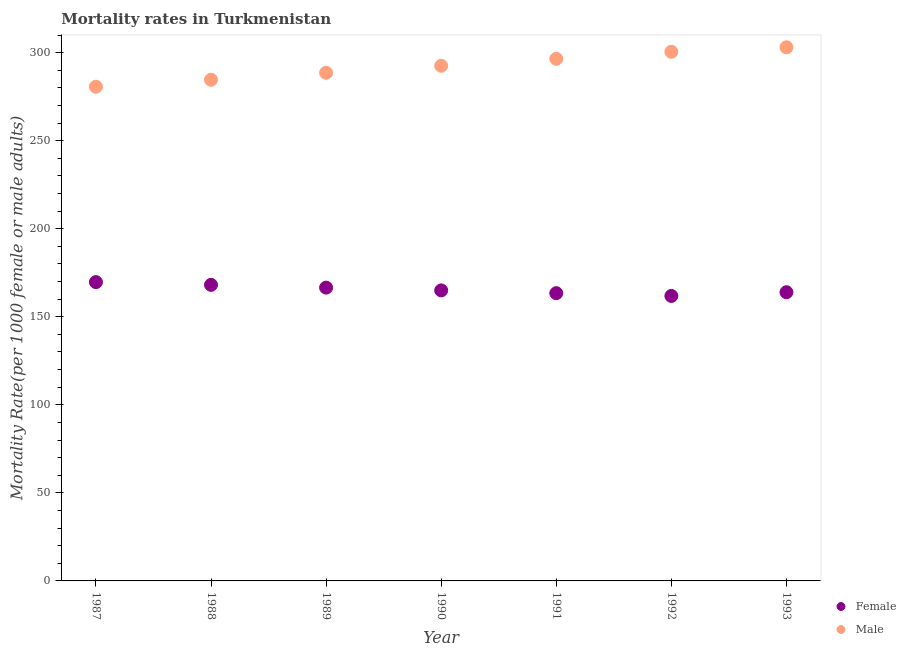How many different coloured dotlines are there?
Make the answer very short. 2. What is the male mortality rate in 1988?
Offer a very short reply. 284.61. Across all years, what is the maximum female mortality rate?
Your answer should be very brief. 169.69. Across all years, what is the minimum male mortality rate?
Offer a terse response. 280.64. In which year was the male mortality rate minimum?
Make the answer very short. 1987. What is the total female mortality rate in the graph?
Your response must be concise. 1158.54. What is the difference between the female mortality rate in 1988 and that in 1990?
Offer a very short reply. 3.14. What is the difference between the female mortality rate in 1990 and the male mortality rate in 1991?
Ensure brevity in your answer.  -131.53. What is the average female mortality rate per year?
Your response must be concise. 165.51. In the year 1993, what is the difference between the female mortality rate and male mortality rate?
Keep it short and to the point. -139.07. What is the ratio of the female mortality rate in 1987 to that in 1989?
Your response must be concise. 1.02. Is the difference between the male mortality rate in 1987 and 1992 greater than the difference between the female mortality rate in 1987 and 1992?
Make the answer very short. No. What is the difference between the highest and the second highest male mortality rate?
Your answer should be very brief. 2.55. What is the difference between the highest and the lowest male mortality rate?
Your answer should be compact. 22.38. In how many years, is the female mortality rate greater than the average female mortality rate taken over all years?
Offer a terse response. 3. Is the sum of the male mortality rate in 1987 and 1990 greater than the maximum female mortality rate across all years?
Give a very brief answer. Yes. Does the male mortality rate monotonically increase over the years?
Make the answer very short. Yes. Is the male mortality rate strictly less than the female mortality rate over the years?
Your answer should be very brief. No. How many dotlines are there?
Your answer should be very brief. 2. What is the difference between two consecutive major ticks on the Y-axis?
Your response must be concise. 50. Are the values on the major ticks of Y-axis written in scientific E-notation?
Your answer should be very brief. No. Does the graph contain any zero values?
Provide a short and direct response. No. Where does the legend appear in the graph?
Offer a terse response. Bottom right. How many legend labels are there?
Offer a very short reply. 2. What is the title of the graph?
Provide a succinct answer. Mortality rates in Turkmenistan. Does "Secondary school" appear as one of the legend labels in the graph?
Your response must be concise. No. What is the label or title of the Y-axis?
Ensure brevity in your answer.  Mortality Rate(per 1000 female or male adults). What is the Mortality Rate(per 1000 female or male adults) of Female in 1987?
Your answer should be compact. 169.69. What is the Mortality Rate(per 1000 female or male adults) of Male in 1987?
Give a very brief answer. 280.64. What is the Mortality Rate(per 1000 female or male adults) of Female in 1988?
Your answer should be very brief. 168.12. What is the Mortality Rate(per 1000 female or male adults) of Male in 1988?
Provide a succinct answer. 284.61. What is the Mortality Rate(per 1000 female or male adults) of Female in 1989?
Give a very brief answer. 166.55. What is the Mortality Rate(per 1000 female or male adults) in Male in 1989?
Make the answer very short. 288.57. What is the Mortality Rate(per 1000 female or male adults) of Female in 1990?
Give a very brief answer. 164.98. What is the Mortality Rate(per 1000 female or male adults) of Male in 1990?
Your answer should be compact. 292.54. What is the Mortality Rate(per 1000 female or male adults) of Female in 1991?
Offer a very short reply. 163.41. What is the Mortality Rate(per 1000 female or male adults) in Male in 1991?
Ensure brevity in your answer.  296.5. What is the Mortality Rate(per 1000 female or male adults) of Female in 1992?
Keep it short and to the point. 161.84. What is the Mortality Rate(per 1000 female or male adults) in Male in 1992?
Ensure brevity in your answer.  300.47. What is the Mortality Rate(per 1000 female or male adults) of Female in 1993?
Provide a succinct answer. 163.95. What is the Mortality Rate(per 1000 female or male adults) in Male in 1993?
Make the answer very short. 303.02. Across all years, what is the maximum Mortality Rate(per 1000 female or male adults) of Female?
Offer a very short reply. 169.69. Across all years, what is the maximum Mortality Rate(per 1000 female or male adults) of Male?
Make the answer very short. 303.02. Across all years, what is the minimum Mortality Rate(per 1000 female or male adults) of Female?
Keep it short and to the point. 161.84. Across all years, what is the minimum Mortality Rate(per 1000 female or male adults) of Male?
Provide a short and direct response. 280.64. What is the total Mortality Rate(per 1000 female or male adults) of Female in the graph?
Your answer should be very brief. 1158.54. What is the total Mortality Rate(per 1000 female or male adults) of Male in the graph?
Your answer should be very brief. 2046.35. What is the difference between the Mortality Rate(per 1000 female or male adults) in Female in 1987 and that in 1988?
Ensure brevity in your answer.  1.57. What is the difference between the Mortality Rate(per 1000 female or male adults) of Male in 1987 and that in 1988?
Give a very brief answer. -3.97. What is the difference between the Mortality Rate(per 1000 female or male adults) in Female in 1987 and that in 1989?
Your answer should be compact. 3.14. What is the difference between the Mortality Rate(per 1000 female or male adults) in Male in 1987 and that in 1989?
Offer a very short reply. -7.93. What is the difference between the Mortality Rate(per 1000 female or male adults) of Female in 1987 and that in 1990?
Offer a very short reply. 4.71. What is the difference between the Mortality Rate(per 1000 female or male adults) of Male in 1987 and that in 1990?
Provide a succinct answer. -11.9. What is the difference between the Mortality Rate(per 1000 female or male adults) of Female in 1987 and that in 1991?
Provide a succinct answer. 6.29. What is the difference between the Mortality Rate(per 1000 female or male adults) in Male in 1987 and that in 1991?
Your answer should be compact. -15.86. What is the difference between the Mortality Rate(per 1000 female or male adults) of Female in 1987 and that in 1992?
Your answer should be compact. 7.86. What is the difference between the Mortality Rate(per 1000 female or male adults) in Male in 1987 and that in 1992?
Your answer should be very brief. -19.83. What is the difference between the Mortality Rate(per 1000 female or male adults) of Female in 1987 and that in 1993?
Provide a succinct answer. 5.75. What is the difference between the Mortality Rate(per 1000 female or male adults) in Male in 1987 and that in 1993?
Your response must be concise. -22.38. What is the difference between the Mortality Rate(per 1000 female or male adults) in Female in 1988 and that in 1989?
Offer a very short reply. 1.57. What is the difference between the Mortality Rate(per 1000 female or male adults) in Male in 1988 and that in 1989?
Offer a terse response. -3.97. What is the difference between the Mortality Rate(per 1000 female or male adults) of Female in 1988 and that in 1990?
Offer a terse response. 3.14. What is the difference between the Mortality Rate(per 1000 female or male adults) in Male in 1988 and that in 1990?
Give a very brief answer. -7.93. What is the difference between the Mortality Rate(per 1000 female or male adults) in Female in 1988 and that in 1991?
Provide a succinct answer. 4.71. What is the difference between the Mortality Rate(per 1000 female or male adults) in Male in 1988 and that in 1991?
Provide a short and direct response. -11.9. What is the difference between the Mortality Rate(per 1000 female or male adults) in Female in 1988 and that in 1992?
Provide a succinct answer. 6.29. What is the difference between the Mortality Rate(per 1000 female or male adults) in Male in 1988 and that in 1992?
Your answer should be compact. -15.86. What is the difference between the Mortality Rate(per 1000 female or male adults) in Female in 1988 and that in 1993?
Keep it short and to the point. 4.17. What is the difference between the Mortality Rate(per 1000 female or male adults) of Male in 1988 and that in 1993?
Ensure brevity in your answer.  -18.41. What is the difference between the Mortality Rate(per 1000 female or male adults) of Female in 1989 and that in 1990?
Ensure brevity in your answer.  1.57. What is the difference between the Mortality Rate(per 1000 female or male adults) of Male in 1989 and that in 1990?
Make the answer very short. -3.96. What is the difference between the Mortality Rate(per 1000 female or male adults) in Female in 1989 and that in 1991?
Your answer should be compact. 3.14. What is the difference between the Mortality Rate(per 1000 female or male adults) in Male in 1989 and that in 1991?
Make the answer very short. -7.93. What is the difference between the Mortality Rate(per 1000 female or male adults) of Female in 1989 and that in 1992?
Ensure brevity in your answer.  4.71. What is the difference between the Mortality Rate(per 1000 female or male adults) in Male in 1989 and that in 1992?
Provide a short and direct response. -11.9. What is the difference between the Mortality Rate(per 1000 female or male adults) in Female in 1989 and that in 1993?
Your answer should be compact. 2.6. What is the difference between the Mortality Rate(per 1000 female or male adults) of Male in 1989 and that in 1993?
Your response must be concise. -14.45. What is the difference between the Mortality Rate(per 1000 female or male adults) in Female in 1990 and that in 1991?
Your answer should be very brief. 1.57. What is the difference between the Mortality Rate(per 1000 female or male adults) of Male in 1990 and that in 1991?
Your answer should be compact. -3.97. What is the difference between the Mortality Rate(per 1000 female or male adults) of Female in 1990 and that in 1992?
Ensure brevity in your answer.  3.14. What is the difference between the Mortality Rate(per 1000 female or male adults) of Male in 1990 and that in 1992?
Provide a short and direct response. -7.93. What is the difference between the Mortality Rate(per 1000 female or male adults) of Female in 1990 and that in 1993?
Make the answer very short. 1.03. What is the difference between the Mortality Rate(per 1000 female or male adults) in Male in 1990 and that in 1993?
Your response must be concise. -10.48. What is the difference between the Mortality Rate(per 1000 female or male adults) in Female in 1991 and that in 1992?
Offer a very short reply. 1.57. What is the difference between the Mortality Rate(per 1000 female or male adults) of Male in 1991 and that in 1992?
Give a very brief answer. -3.96. What is the difference between the Mortality Rate(per 1000 female or male adults) of Female in 1991 and that in 1993?
Your response must be concise. -0.54. What is the difference between the Mortality Rate(per 1000 female or male adults) in Male in 1991 and that in 1993?
Provide a succinct answer. -6.52. What is the difference between the Mortality Rate(per 1000 female or male adults) of Female in 1992 and that in 1993?
Your answer should be very brief. -2.11. What is the difference between the Mortality Rate(per 1000 female or male adults) in Male in 1992 and that in 1993?
Give a very brief answer. -2.55. What is the difference between the Mortality Rate(per 1000 female or male adults) in Female in 1987 and the Mortality Rate(per 1000 female or male adults) in Male in 1988?
Keep it short and to the point. -114.91. What is the difference between the Mortality Rate(per 1000 female or male adults) in Female in 1987 and the Mortality Rate(per 1000 female or male adults) in Male in 1989?
Provide a succinct answer. -118.88. What is the difference between the Mortality Rate(per 1000 female or male adults) of Female in 1987 and the Mortality Rate(per 1000 female or male adults) of Male in 1990?
Offer a very short reply. -122.84. What is the difference between the Mortality Rate(per 1000 female or male adults) of Female in 1987 and the Mortality Rate(per 1000 female or male adults) of Male in 1991?
Make the answer very short. -126.81. What is the difference between the Mortality Rate(per 1000 female or male adults) in Female in 1987 and the Mortality Rate(per 1000 female or male adults) in Male in 1992?
Offer a very short reply. -130.78. What is the difference between the Mortality Rate(per 1000 female or male adults) of Female in 1987 and the Mortality Rate(per 1000 female or male adults) of Male in 1993?
Provide a short and direct response. -133.33. What is the difference between the Mortality Rate(per 1000 female or male adults) in Female in 1988 and the Mortality Rate(per 1000 female or male adults) in Male in 1989?
Your answer should be very brief. -120.45. What is the difference between the Mortality Rate(per 1000 female or male adults) in Female in 1988 and the Mortality Rate(per 1000 female or male adults) in Male in 1990?
Offer a very short reply. -124.42. What is the difference between the Mortality Rate(per 1000 female or male adults) in Female in 1988 and the Mortality Rate(per 1000 female or male adults) in Male in 1991?
Offer a terse response. -128.38. What is the difference between the Mortality Rate(per 1000 female or male adults) in Female in 1988 and the Mortality Rate(per 1000 female or male adults) in Male in 1992?
Give a very brief answer. -132.35. What is the difference between the Mortality Rate(per 1000 female or male adults) of Female in 1988 and the Mortality Rate(per 1000 female or male adults) of Male in 1993?
Provide a short and direct response. -134.9. What is the difference between the Mortality Rate(per 1000 female or male adults) in Female in 1989 and the Mortality Rate(per 1000 female or male adults) in Male in 1990?
Offer a very short reply. -125.99. What is the difference between the Mortality Rate(per 1000 female or male adults) in Female in 1989 and the Mortality Rate(per 1000 female or male adults) in Male in 1991?
Keep it short and to the point. -129.95. What is the difference between the Mortality Rate(per 1000 female or male adults) in Female in 1989 and the Mortality Rate(per 1000 female or male adults) in Male in 1992?
Your response must be concise. -133.92. What is the difference between the Mortality Rate(per 1000 female or male adults) in Female in 1989 and the Mortality Rate(per 1000 female or male adults) in Male in 1993?
Offer a terse response. -136.47. What is the difference between the Mortality Rate(per 1000 female or male adults) in Female in 1990 and the Mortality Rate(per 1000 female or male adults) in Male in 1991?
Your answer should be very brief. -131.53. What is the difference between the Mortality Rate(per 1000 female or male adults) in Female in 1990 and the Mortality Rate(per 1000 female or male adults) in Male in 1992?
Provide a succinct answer. -135.49. What is the difference between the Mortality Rate(per 1000 female or male adults) of Female in 1990 and the Mortality Rate(per 1000 female or male adults) of Male in 1993?
Your response must be concise. -138.04. What is the difference between the Mortality Rate(per 1000 female or male adults) of Female in 1991 and the Mortality Rate(per 1000 female or male adults) of Male in 1992?
Give a very brief answer. -137.06. What is the difference between the Mortality Rate(per 1000 female or male adults) in Female in 1991 and the Mortality Rate(per 1000 female or male adults) in Male in 1993?
Provide a short and direct response. -139.61. What is the difference between the Mortality Rate(per 1000 female or male adults) of Female in 1992 and the Mortality Rate(per 1000 female or male adults) of Male in 1993?
Offer a terse response. -141.19. What is the average Mortality Rate(per 1000 female or male adults) of Female per year?
Give a very brief answer. 165.51. What is the average Mortality Rate(per 1000 female or male adults) in Male per year?
Provide a short and direct response. 292.34. In the year 1987, what is the difference between the Mortality Rate(per 1000 female or male adults) of Female and Mortality Rate(per 1000 female or male adults) of Male?
Offer a very short reply. -110.95. In the year 1988, what is the difference between the Mortality Rate(per 1000 female or male adults) in Female and Mortality Rate(per 1000 female or male adults) in Male?
Give a very brief answer. -116.48. In the year 1989, what is the difference between the Mortality Rate(per 1000 female or male adults) of Female and Mortality Rate(per 1000 female or male adults) of Male?
Your answer should be compact. -122.02. In the year 1990, what is the difference between the Mortality Rate(per 1000 female or male adults) of Female and Mortality Rate(per 1000 female or male adults) of Male?
Keep it short and to the point. -127.56. In the year 1991, what is the difference between the Mortality Rate(per 1000 female or male adults) of Female and Mortality Rate(per 1000 female or male adults) of Male?
Offer a very short reply. -133.1. In the year 1992, what is the difference between the Mortality Rate(per 1000 female or male adults) in Female and Mortality Rate(per 1000 female or male adults) in Male?
Offer a very short reply. -138.63. In the year 1993, what is the difference between the Mortality Rate(per 1000 female or male adults) of Female and Mortality Rate(per 1000 female or male adults) of Male?
Offer a very short reply. -139.07. What is the ratio of the Mortality Rate(per 1000 female or male adults) of Female in 1987 to that in 1988?
Provide a short and direct response. 1.01. What is the ratio of the Mortality Rate(per 1000 female or male adults) of Male in 1987 to that in 1988?
Give a very brief answer. 0.99. What is the ratio of the Mortality Rate(per 1000 female or male adults) in Female in 1987 to that in 1989?
Offer a terse response. 1.02. What is the ratio of the Mortality Rate(per 1000 female or male adults) of Male in 1987 to that in 1989?
Keep it short and to the point. 0.97. What is the ratio of the Mortality Rate(per 1000 female or male adults) of Female in 1987 to that in 1990?
Your answer should be very brief. 1.03. What is the ratio of the Mortality Rate(per 1000 female or male adults) of Male in 1987 to that in 1990?
Your response must be concise. 0.96. What is the ratio of the Mortality Rate(per 1000 female or male adults) of Female in 1987 to that in 1991?
Ensure brevity in your answer.  1.04. What is the ratio of the Mortality Rate(per 1000 female or male adults) in Male in 1987 to that in 1991?
Your answer should be very brief. 0.95. What is the ratio of the Mortality Rate(per 1000 female or male adults) in Female in 1987 to that in 1992?
Keep it short and to the point. 1.05. What is the ratio of the Mortality Rate(per 1000 female or male adults) in Male in 1987 to that in 1992?
Offer a terse response. 0.93. What is the ratio of the Mortality Rate(per 1000 female or male adults) in Female in 1987 to that in 1993?
Provide a succinct answer. 1.03. What is the ratio of the Mortality Rate(per 1000 female or male adults) of Male in 1987 to that in 1993?
Provide a short and direct response. 0.93. What is the ratio of the Mortality Rate(per 1000 female or male adults) of Female in 1988 to that in 1989?
Make the answer very short. 1.01. What is the ratio of the Mortality Rate(per 1000 female or male adults) of Male in 1988 to that in 1989?
Make the answer very short. 0.99. What is the ratio of the Mortality Rate(per 1000 female or male adults) of Female in 1988 to that in 1990?
Provide a succinct answer. 1.02. What is the ratio of the Mortality Rate(per 1000 female or male adults) of Male in 1988 to that in 1990?
Your answer should be compact. 0.97. What is the ratio of the Mortality Rate(per 1000 female or male adults) of Female in 1988 to that in 1991?
Keep it short and to the point. 1.03. What is the ratio of the Mortality Rate(per 1000 female or male adults) of Male in 1988 to that in 1991?
Ensure brevity in your answer.  0.96. What is the ratio of the Mortality Rate(per 1000 female or male adults) of Female in 1988 to that in 1992?
Make the answer very short. 1.04. What is the ratio of the Mortality Rate(per 1000 female or male adults) of Male in 1988 to that in 1992?
Provide a succinct answer. 0.95. What is the ratio of the Mortality Rate(per 1000 female or male adults) in Female in 1988 to that in 1993?
Offer a very short reply. 1.03. What is the ratio of the Mortality Rate(per 1000 female or male adults) of Male in 1988 to that in 1993?
Your answer should be compact. 0.94. What is the ratio of the Mortality Rate(per 1000 female or male adults) in Female in 1989 to that in 1990?
Your answer should be very brief. 1.01. What is the ratio of the Mortality Rate(per 1000 female or male adults) in Male in 1989 to that in 1990?
Provide a short and direct response. 0.99. What is the ratio of the Mortality Rate(per 1000 female or male adults) in Female in 1989 to that in 1991?
Your answer should be very brief. 1.02. What is the ratio of the Mortality Rate(per 1000 female or male adults) of Male in 1989 to that in 1991?
Keep it short and to the point. 0.97. What is the ratio of the Mortality Rate(per 1000 female or male adults) in Female in 1989 to that in 1992?
Offer a very short reply. 1.03. What is the ratio of the Mortality Rate(per 1000 female or male adults) of Male in 1989 to that in 1992?
Give a very brief answer. 0.96. What is the ratio of the Mortality Rate(per 1000 female or male adults) in Female in 1989 to that in 1993?
Your answer should be very brief. 1.02. What is the ratio of the Mortality Rate(per 1000 female or male adults) of Male in 1989 to that in 1993?
Your answer should be compact. 0.95. What is the ratio of the Mortality Rate(per 1000 female or male adults) in Female in 1990 to that in 1991?
Provide a succinct answer. 1.01. What is the ratio of the Mortality Rate(per 1000 female or male adults) of Male in 1990 to that in 1991?
Your answer should be compact. 0.99. What is the ratio of the Mortality Rate(per 1000 female or male adults) of Female in 1990 to that in 1992?
Make the answer very short. 1.02. What is the ratio of the Mortality Rate(per 1000 female or male adults) in Male in 1990 to that in 1992?
Offer a very short reply. 0.97. What is the ratio of the Mortality Rate(per 1000 female or male adults) of Male in 1990 to that in 1993?
Offer a very short reply. 0.97. What is the ratio of the Mortality Rate(per 1000 female or male adults) in Female in 1991 to that in 1992?
Offer a very short reply. 1.01. What is the ratio of the Mortality Rate(per 1000 female or male adults) of Male in 1991 to that in 1993?
Provide a short and direct response. 0.98. What is the ratio of the Mortality Rate(per 1000 female or male adults) in Female in 1992 to that in 1993?
Offer a terse response. 0.99. What is the difference between the highest and the second highest Mortality Rate(per 1000 female or male adults) of Female?
Keep it short and to the point. 1.57. What is the difference between the highest and the second highest Mortality Rate(per 1000 female or male adults) of Male?
Ensure brevity in your answer.  2.55. What is the difference between the highest and the lowest Mortality Rate(per 1000 female or male adults) of Female?
Offer a very short reply. 7.86. What is the difference between the highest and the lowest Mortality Rate(per 1000 female or male adults) in Male?
Offer a terse response. 22.38. 